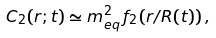Convert formula to latex. <formula><loc_0><loc_0><loc_500><loc_500>C _ { 2 } ( r ; t ) \simeq m _ { e q } ^ { 2 } \, f _ { 2 } ( r / R ( t ) ) \, ,</formula> 